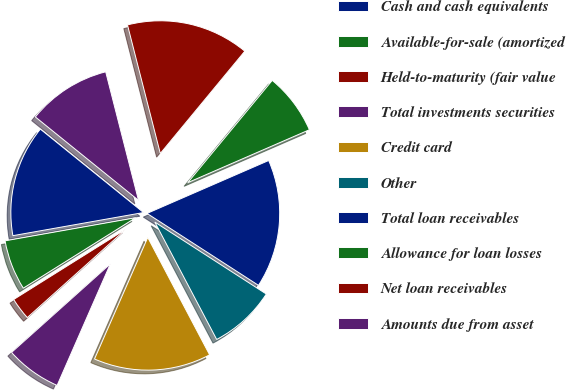<chart> <loc_0><loc_0><loc_500><loc_500><pie_chart><fcel>Cash and cash equivalents<fcel>Available-for-sale (amortized<fcel>Held-to-maturity (fair value<fcel>Total investments securities<fcel>Credit card<fcel>Other<fcel>Total loan receivables<fcel>Allowance for loan losses<fcel>Net loan receivables<fcel>Amounts due from asset<nl><fcel>13.61%<fcel>6.12%<fcel>2.72%<fcel>6.8%<fcel>14.29%<fcel>8.16%<fcel>15.65%<fcel>7.48%<fcel>14.97%<fcel>10.2%<nl></chart> 